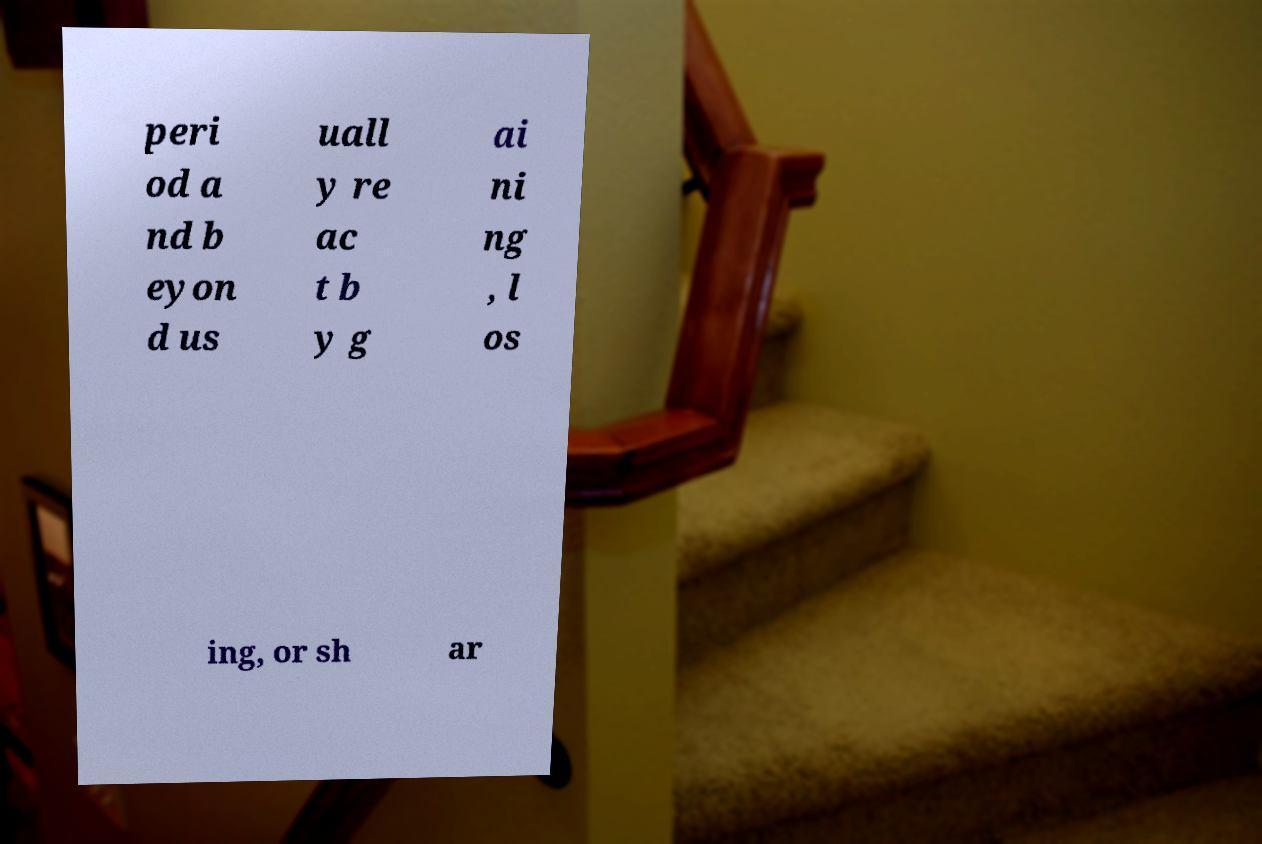Please identify and transcribe the text found in this image. peri od a nd b eyon d us uall y re ac t b y g ai ni ng , l os ing, or sh ar 